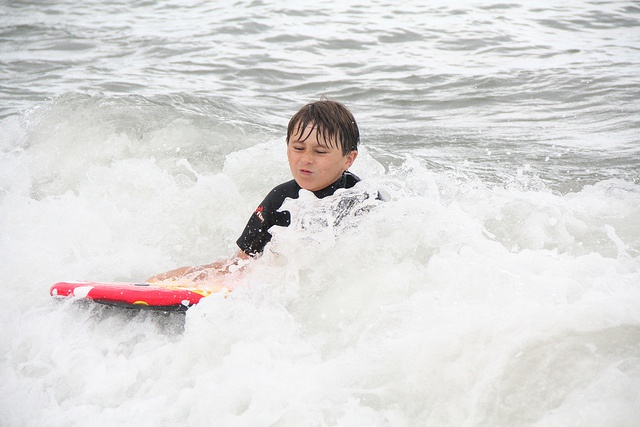Describe the objects in this image and their specific colors. I can see people in darkgray, black, lightgray, tan, and gray tones and surfboard in darkgray, lightgray, salmon, lightpink, and red tones in this image. 